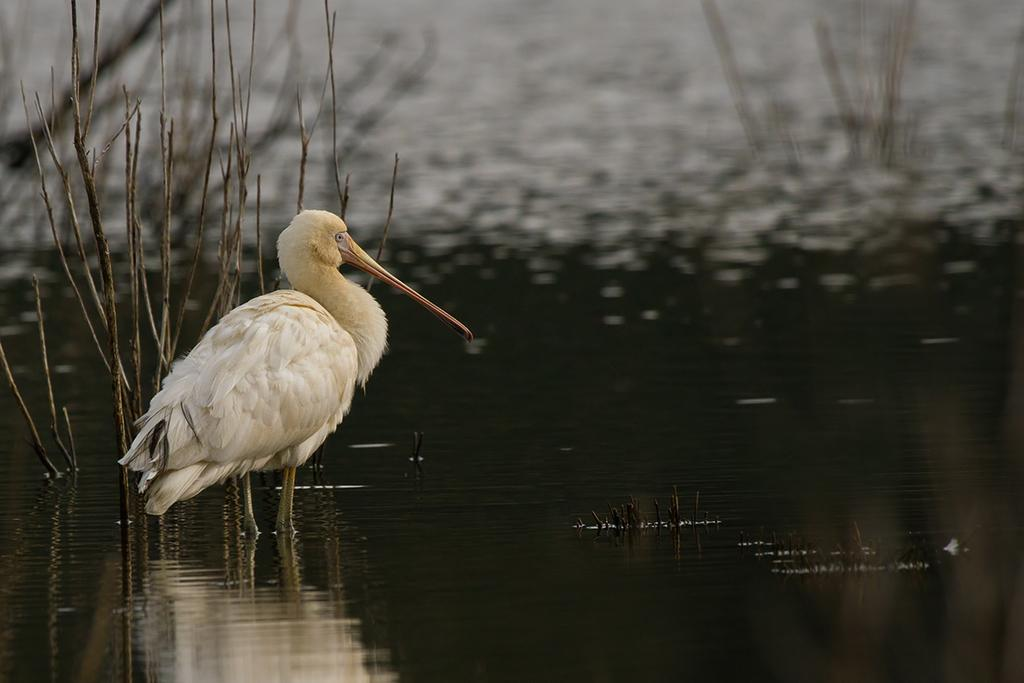What type of bird is in the image? There is a white color crane in the image. Where is the crane located in the image? The crane is standing in the water. What is the primary element in the image? Water is present in the image. What can be seen in the background of the image? There is a dry plant and water visible in the background of the image. What type of advertisement can be seen in the image? There is no advertisement present in the image; it features a white color crane standing in the water. What type of market is depicted in the image? There is no market depicted in the image; it features a white color crane standing in the water. 